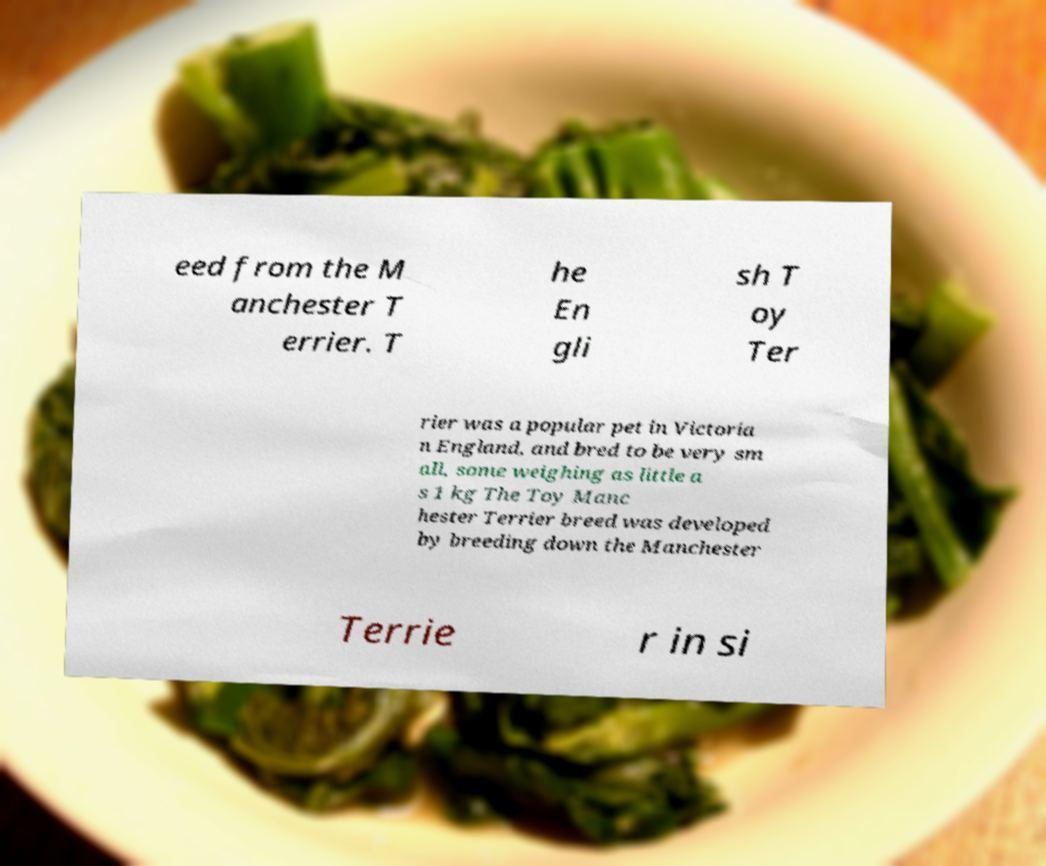For documentation purposes, I need the text within this image transcribed. Could you provide that? eed from the M anchester T errier. T he En gli sh T oy Ter rier was a popular pet in Victoria n England, and bred to be very sm all, some weighing as little a s 1 kg The Toy Manc hester Terrier breed was developed by breeding down the Manchester Terrie r in si 